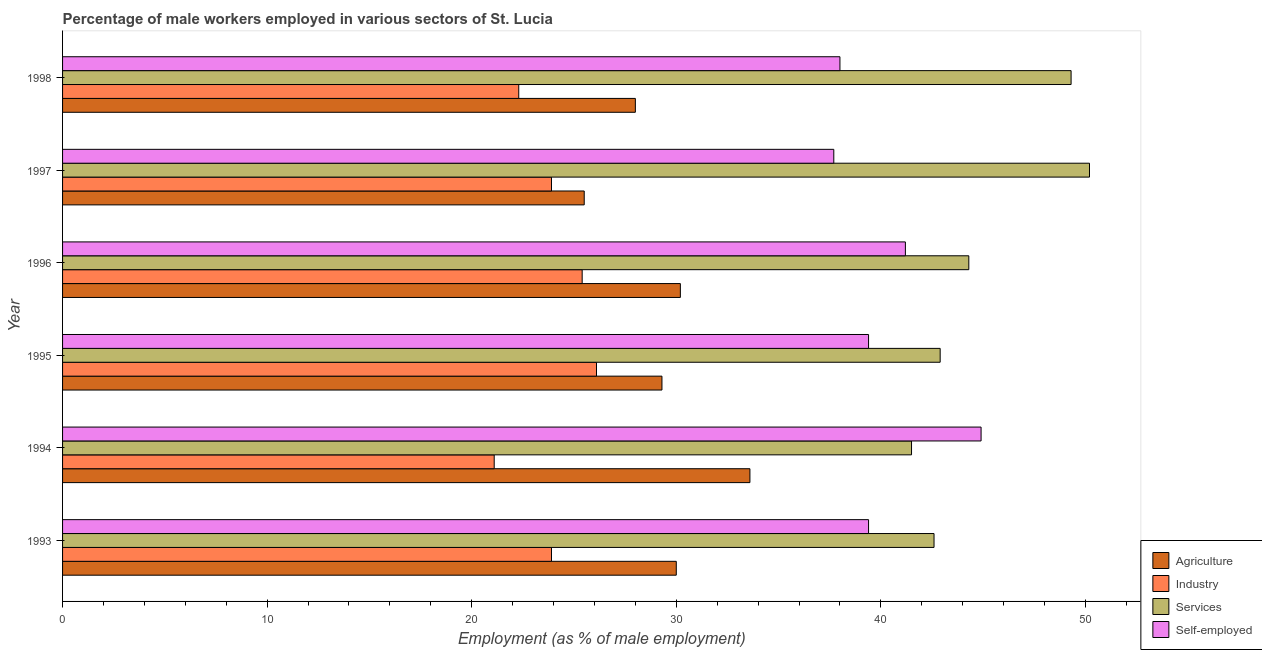How many different coloured bars are there?
Your response must be concise. 4. Are the number of bars on each tick of the Y-axis equal?
Ensure brevity in your answer.  Yes. How many bars are there on the 6th tick from the top?
Give a very brief answer. 4. What is the label of the 5th group of bars from the top?
Give a very brief answer. 1994. What is the percentage of self employed male workers in 1997?
Make the answer very short. 37.7. Across all years, what is the maximum percentage of male workers in services?
Ensure brevity in your answer.  50.2. Across all years, what is the minimum percentage of male workers in agriculture?
Offer a very short reply. 25.5. What is the total percentage of self employed male workers in the graph?
Offer a terse response. 240.6. What is the difference between the percentage of male workers in services in 1996 and that in 1997?
Provide a succinct answer. -5.9. What is the difference between the percentage of male workers in agriculture in 1997 and the percentage of self employed male workers in 1996?
Provide a short and direct response. -15.7. What is the average percentage of male workers in industry per year?
Make the answer very short. 23.78. In the year 1993, what is the difference between the percentage of self employed male workers and percentage of male workers in services?
Your answer should be very brief. -3.2. What is the ratio of the percentage of male workers in industry in 1995 to that in 1997?
Provide a short and direct response. 1.09. Is the percentage of self employed male workers in 1993 less than that in 1997?
Provide a short and direct response. No. Is the difference between the percentage of male workers in industry in 1994 and 1996 greater than the difference between the percentage of self employed male workers in 1994 and 1996?
Your response must be concise. No. Is the sum of the percentage of self employed male workers in 1995 and 1996 greater than the maximum percentage of male workers in services across all years?
Your response must be concise. Yes. What does the 4th bar from the top in 1997 represents?
Give a very brief answer. Agriculture. What does the 3rd bar from the bottom in 1994 represents?
Provide a short and direct response. Services. Are all the bars in the graph horizontal?
Offer a terse response. Yes. Are the values on the major ticks of X-axis written in scientific E-notation?
Provide a succinct answer. No. Does the graph contain any zero values?
Make the answer very short. No. Does the graph contain grids?
Keep it short and to the point. No. Where does the legend appear in the graph?
Your response must be concise. Bottom right. What is the title of the graph?
Make the answer very short. Percentage of male workers employed in various sectors of St. Lucia. What is the label or title of the X-axis?
Offer a terse response. Employment (as % of male employment). What is the label or title of the Y-axis?
Provide a short and direct response. Year. What is the Employment (as % of male employment) of Industry in 1993?
Provide a succinct answer. 23.9. What is the Employment (as % of male employment) in Services in 1993?
Keep it short and to the point. 42.6. What is the Employment (as % of male employment) of Self-employed in 1993?
Provide a succinct answer. 39.4. What is the Employment (as % of male employment) of Agriculture in 1994?
Make the answer very short. 33.6. What is the Employment (as % of male employment) in Industry in 1994?
Provide a succinct answer. 21.1. What is the Employment (as % of male employment) in Services in 1994?
Ensure brevity in your answer.  41.5. What is the Employment (as % of male employment) of Self-employed in 1994?
Offer a very short reply. 44.9. What is the Employment (as % of male employment) of Agriculture in 1995?
Provide a short and direct response. 29.3. What is the Employment (as % of male employment) of Industry in 1995?
Provide a short and direct response. 26.1. What is the Employment (as % of male employment) of Services in 1995?
Offer a terse response. 42.9. What is the Employment (as % of male employment) in Self-employed in 1995?
Provide a short and direct response. 39.4. What is the Employment (as % of male employment) in Agriculture in 1996?
Provide a short and direct response. 30.2. What is the Employment (as % of male employment) of Industry in 1996?
Ensure brevity in your answer.  25.4. What is the Employment (as % of male employment) in Services in 1996?
Provide a short and direct response. 44.3. What is the Employment (as % of male employment) of Self-employed in 1996?
Keep it short and to the point. 41.2. What is the Employment (as % of male employment) of Industry in 1997?
Keep it short and to the point. 23.9. What is the Employment (as % of male employment) in Services in 1997?
Provide a succinct answer. 50.2. What is the Employment (as % of male employment) in Self-employed in 1997?
Provide a succinct answer. 37.7. What is the Employment (as % of male employment) in Agriculture in 1998?
Make the answer very short. 28. What is the Employment (as % of male employment) of Industry in 1998?
Your answer should be very brief. 22.3. What is the Employment (as % of male employment) of Services in 1998?
Keep it short and to the point. 49.3. Across all years, what is the maximum Employment (as % of male employment) in Agriculture?
Offer a terse response. 33.6. Across all years, what is the maximum Employment (as % of male employment) of Industry?
Offer a terse response. 26.1. Across all years, what is the maximum Employment (as % of male employment) in Services?
Offer a very short reply. 50.2. Across all years, what is the maximum Employment (as % of male employment) of Self-employed?
Offer a very short reply. 44.9. Across all years, what is the minimum Employment (as % of male employment) of Industry?
Offer a terse response. 21.1. Across all years, what is the minimum Employment (as % of male employment) of Services?
Give a very brief answer. 41.5. Across all years, what is the minimum Employment (as % of male employment) in Self-employed?
Keep it short and to the point. 37.7. What is the total Employment (as % of male employment) in Agriculture in the graph?
Your answer should be very brief. 176.6. What is the total Employment (as % of male employment) in Industry in the graph?
Your response must be concise. 142.7. What is the total Employment (as % of male employment) in Services in the graph?
Offer a very short reply. 270.8. What is the total Employment (as % of male employment) of Self-employed in the graph?
Provide a succinct answer. 240.6. What is the difference between the Employment (as % of male employment) of Agriculture in 1993 and that in 1994?
Make the answer very short. -3.6. What is the difference between the Employment (as % of male employment) in Self-employed in 1993 and that in 1994?
Your answer should be compact. -5.5. What is the difference between the Employment (as % of male employment) in Agriculture in 1993 and that in 1995?
Keep it short and to the point. 0.7. What is the difference between the Employment (as % of male employment) of Services in 1993 and that in 1995?
Offer a terse response. -0.3. What is the difference between the Employment (as % of male employment) in Agriculture in 1993 and that in 1996?
Keep it short and to the point. -0.2. What is the difference between the Employment (as % of male employment) in Services in 1993 and that in 1996?
Ensure brevity in your answer.  -1.7. What is the difference between the Employment (as % of male employment) in Agriculture in 1993 and that in 1997?
Provide a short and direct response. 4.5. What is the difference between the Employment (as % of male employment) of Industry in 1993 and that in 1998?
Your response must be concise. 1.6. What is the difference between the Employment (as % of male employment) of Services in 1993 and that in 1998?
Give a very brief answer. -6.7. What is the difference between the Employment (as % of male employment) in Services in 1994 and that in 1995?
Offer a terse response. -1.4. What is the difference between the Employment (as % of male employment) in Agriculture in 1994 and that in 1996?
Give a very brief answer. 3.4. What is the difference between the Employment (as % of male employment) in Services in 1994 and that in 1996?
Give a very brief answer. -2.8. What is the difference between the Employment (as % of male employment) of Self-employed in 1994 and that in 1996?
Give a very brief answer. 3.7. What is the difference between the Employment (as % of male employment) of Agriculture in 1994 and that in 1997?
Keep it short and to the point. 8.1. What is the difference between the Employment (as % of male employment) of Industry in 1994 and that in 1997?
Your answer should be compact. -2.8. What is the difference between the Employment (as % of male employment) in Agriculture in 1994 and that in 1998?
Offer a very short reply. 5.6. What is the difference between the Employment (as % of male employment) of Industry in 1994 and that in 1998?
Make the answer very short. -1.2. What is the difference between the Employment (as % of male employment) in Services in 1995 and that in 1996?
Provide a short and direct response. -1.4. What is the difference between the Employment (as % of male employment) of Agriculture in 1995 and that in 1997?
Your response must be concise. 3.8. What is the difference between the Employment (as % of male employment) in Services in 1995 and that in 1997?
Your answer should be very brief. -7.3. What is the difference between the Employment (as % of male employment) of Self-employed in 1995 and that in 1997?
Ensure brevity in your answer.  1.7. What is the difference between the Employment (as % of male employment) of Agriculture in 1995 and that in 1998?
Ensure brevity in your answer.  1.3. What is the difference between the Employment (as % of male employment) of Industry in 1995 and that in 1998?
Your response must be concise. 3.8. What is the difference between the Employment (as % of male employment) of Services in 1995 and that in 1998?
Offer a very short reply. -6.4. What is the difference between the Employment (as % of male employment) of Industry in 1996 and that in 1997?
Provide a short and direct response. 1.5. What is the difference between the Employment (as % of male employment) in Agriculture in 1996 and that in 1998?
Make the answer very short. 2.2. What is the difference between the Employment (as % of male employment) of Industry in 1996 and that in 1998?
Your response must be concise. 3.1. What is the difference between the Employment (as % of male employment) in Services in 1996 and that in 1998?
Offer a very short reply. -5. What is the difference between the Employment (as % of male employment) in Industry in 1997 and that in 1998?
Offer a terse response. 1.6. What is the difference between the Employment (as % of male employment) in Services in 1997 and that in 1998?
Your response must be concise. 0.9. What is the difference between the Employment (as % of male employment) in Self-employed in 1997 and that in 1998?
Ensure brevity in your answer.  -0.3. What is the difference between the Employment (as % of male employment) in Agriculture in 1993 and the Employment (as % of male employment) in Services in 1994?
Provide a short and direct response. -11.5. What is the difference between the Employment (as % of male employment) in Agriculture in 1993 and the Employment (as % of male employment) in Self-employed in 1994?
Provide a short and direct response. -14.9. What is the difference between the Employment (as % of male employment) of Industry in 1993 and the Employment (as % of male employment) of Services in 1994?
Offer a very short reply. -17.6. What is the difference between the Employment (as % of male employment) of Industry in 1993 and the Employment (as % of male employment) of Self-employed in 1994?
Your answer should be compact. -21. What is the difference between the Employment (as % of male employment) of Services in 1993 and the Employment (as % of male employment) of Self-employed in 1994?
Offer a very short reply. -2.3. What is the difference between the Employment (as % of male employment) in Agriculture in 1993 and the Employment (as % of male employment) in Industry in 1995?
Your response must be concise. 3.9. What is the difference between the Employment (as % of male employment) of Agriculture in 1993 and the Employment (as % of male employment) of Services in 1995?
Ensure brevity in your answer.  -12.9. What is the difference between the Employment (as % of male employment) in Agriculture in 1993 and the Employment (as % of male employment) in Self-employed in 1995?
Ensure brevity in your answer.  -9.4. What is the difference between the Employment (as % of male employment) of Industry in 1993 and the Employment (as % of male employment) of Self-employed in 1995?
Make the answer very short. -15.5. What is the difference between the Employment (as % of male employment) of Services in 1993 and the Employment (as % of male employment) of Self-employed in 1995?
Offer a very short reply. 3.2. What is the difference between the Employment (as % of male employment) in Agriculture in 1993 and the Employment (as % of male employment) in Services in 1996?
Make the answer very short. -14.3. What is the difference between the Employment (as % of male employment) in Agriculture in 1993 and the Employment (as % of male employment) in Self-employed in 1996?
Provide a succinct answer. -11.2. What is the difference between the Employment (as % of male employment) of Industry in 1993 and the Employment (as % of male employment) of Services in 1996?
Make the answer very short. -20.4. What is the difference between the Employment (as % of male employment) in Industry in 1993 and the Employment (as % of male employment) in Self-employed in 1996?
Your answer should be compact. -17.3. What is the difference between the Employment (as % of male employment) in Agriculture in 1993 and the Employment (as % of male employment) in Services in 1997?
Offer a very short reply. -20.2. What is the difference between the Employment (as % of male employment) of Industry in 1993 and the Employment (as % of male employment) of Services in 1997?
Your answer should be very brief. -26.3. What is the difference between the Employment (as % of male employment) in Industry in 1993 and the Employment (as % of male employment) in Self-employed in 1997?
Keep it short and to the point. -13.8. What is the difference between the Employment (as % of male employment) of Services in 1993 and the Employment (as % of male employment) of Self-employed in 1997?
Offer a very short reply. 4.9. What is the difference between the Employment (as % of male employment) in Agriculture in 1993 and the Employment (as % of male employment) in Industry in 1998?
Your response must be concise. 7.7. What is the difference between the Employment (as % of male employment) in Agriculture in 1993 and the Employment (as % of male employment) in Services in 1998?
Offer a very short reply. -19.3. What is the difference between the Employment (as % of male employment) in Industry in 1993 and the Employment (as % of male employment) in Services in 1998?
Provide a short and direct response. -25.4. What is the difference between the Employment (as % of male employment) in Industry in 1993 and the Employment (as % of male employment) in Self-employed in 1998?
Your response must be concise. -14.1. What is the difference between the Employment (as % of male employment) of Agriculture in 1994 and the Employment (as % of male employment) of Services in 1995?
Your answer should be very brief. -9.3. What is the difference between the Employment (as % of male employment) of Agriculture in 1994 and the Employment (as % of male employment) of Self-employed in 1995?
Make the answer very short. -5.8. What is the difference between the Employment (as % of male employment) in Industry in 1994 and the Employment (as % of male employment) in Services in 1995?
Your answer should be very brief. -21.8. What is the difference between the Employment (as % of male employment) of Industry in 1994 and the Employment (as % of male employment) of Self-employed in 1995?
Offer a very short reply. -18.3. What is the difference between the Employment (as % of male employment) of Agriculture in 1994 and the Employment (as % of male employment) of Services in 1996?
Provide a short and direct response. -10.7. What is the difference between the Employment (as % of male employment) in Industry in 1994 and the Employment (as % of male employment) in Services in 1996?
Provide a succinct answer. -23.2. What is the difference between the Employment (as % of male employment) in Industry in 1994 and the Employment (as % of male employment) in Self-employed in 1996?
Provide a short and direct response. -20.1. What is the difference between the Employment (as % of male employment) of Services in 1994 and the Employment (as % of male employment) of Self-employed in 1996?
Make the answer very short. 0.3. What is the difference between the Employment (as % of male employment) in Agriculture in 1994 and the Employment (as % of male employment) in Services in 1997?
Keep it short and to the point. -16.6. What is the difference between the Employment (as % of male employment) in Agriculture in 1994 and the Employment (as % of male employment) in Self-employed in 1997?
Offer a terse response. -4.1. What is the difference between the Employment (as % of male employment) in Industry in 1994 and the Employment (as % of male employment) in Services in 1997?
Ensure brevity in your answer.  -29.1. What is the difference between the Employment (as % of male employment) of Industry in 1994 and the Employment (as % of male employment) of Self-employed in 1997?
Offer a very short reply. -16.6. What is the difference between the Employment (as % of male employment) in Agriculture in 1994 and the Employment (as % of male employment) in Services in 1998?
Offer a very short reply. -15.7. What is the difference between the Employment (as % of male employment) of Industry in 1994 and the Employment (as % of male employment) of Services in 1998?
Your answer should be compact. -28.2. What is the difference between the Employment (as % of male employment) in Industry in 1994 and the Employment (as % of male employment) in Self-employed in 1998?
Ensure brevity in your answer.  -16.9. What is the difference between the Employment (as % of male employment) of Agriculture in 1995 and the Employment (as % of male employment) of Industry in 1996?
Your response must be concise. 3.9. What is the difference between the Employment (as % of male employment) in Agriculture in 1995 and the Employment (as % of male employment) in Services in 1996?
Keep it short and to the point. -15. What is the difference between the Employment (as % of male employment) in Industry in 1995 and the Employment (as % of male employment) in Services in 1996?
Ensure brevity in your answer.  -18.2. What is the difference between the Employment (as % of male employment) in Industry in 1995 and the Employment (as % of male employment) in Self-employed in 1996?
Give a very brief answer. -15.1. What is the difference between the Employment (as % of male employment) in Agriculture in 1995 and the Employment (as % of male employment) in Services in 1997?
Provide a short and direct response. -20.9. What is the difference between the Employment (as % of male employment) of Agriculture in 1995 and the Employment (as % of male employment) of Self-employed in 1997?
Your answer should be very brief. -8.4. What is the difference between the Employment (as % of male employment) in Industry in 1995 and the Employment (as % of male employment) in Services in 1997?
Your response must be concise. -24.1. What is the difference between the Employment (as % of male employment) of Agriculture in 1995 and the Employment (as % of male employment) of Services in 1998?
Make the answer very short. -20. What is the difference between the Employment (as % of male employment) in Agriculture in 1995 and the Employment (as % of male employment) in Self-employed in 1998?
Your response must be concise. -8.7. What is the difference between the Employment (as % of male employment) of Industry in 1995 and the Employment (as % of male employment) of Services in 1998?
Provide a short and direct response. -23.2. What is the difference between the Employment (as % of male employment) in Agriculture in 1996 and the Employment (as % of male employment) in Industry in 1997?
Your answer should be compact. 6.3. What is the difference between the Employment (as % of male employment) in Industry in 1996 and the Employment (as % of male employment) in Services in 1997?
Your response must be concise. -24.8. What is the difference between the Employment (as % of male employment) in Industry in 1996 and the Employment (as % of male employment) in Self-employed in 1997?
Give a very brief answer. -12.3. What is the difference between the Employment (as % of male employment) in Agriculture in 1996 and the Employment (as % of male employment) in Industry in 1998?
Your response must be concise. 7.9. What is the difference between the Employment (as % of male employment) in Agriculture in 1996 and the Employment (as % of male employment) in Services in 1998?
Provide a succinct answer. -19.1. What is the difference between the Employment (as % of male employment) of Industry in 1996 and the Employment (as % of male employment) of Services in 1998?
Keep it short and to the point. -23.9. What is the difference between the Employment (as % of male employment) of Services in 1996 and the Employment (as % of male employment) of Self-employed in 1998?
Your response must be concise. 6.3. What is the difference between the Employment (as % of male employment) of Agriculture in 1997 and the Employment (as % of male employment) of Services in 1998?
Give a very brief answer. -23.8. What is the difference between the Employment (as % of male employment) of Industry in 1997 and the Employment (as % of male employment) of Services in 1998?
Ensure brevity in your answer.  -25.4. What is the difference between the Employment (as % of male employment) in Industry in 1997 and the Employment (as % of male employment) in Self-employed in 1998?
Offer a terse response. -14.1. What is the average Employment (as % of male employment) of Agriculture per year?
Make the answer very short. 29.43. What is the average Employment (as % of male employment) of Industry per year?
Keep it short and to the point. 23.78. What is the average Employment (as % of male employment) in Services per year?
Your answer should be very brief. 45.13. What is the average Employment (as % of male employment) of Self-employed per year?
Your answer should be very brief. 40.1. In the year 1993, what is the difference between the Employment (as % of male employment) in Agriculture and Employment (as % of male employment) in Industry?
Make the answer very short. 6.1. In the year 1993, what is the difference between the Employment (as % of male employment) of Agriculture and Employment (as % of male employment) of Services?
Keep it short and to the point. -12.6. In the year 1993, what is the difference between the Employment (as % of male employment) of Agriculture and Employment (as % of male employment) of Self-employed?
Ensure brevity in your answer.  -9.4. In the year 1993, what is the difference between the Employment (as % of male employment) of Industry and Employment (as % of male employment) of Services?
Give a very brief answer. -18.7. In the year 1993, what is the difference between the Employment (as % of male employment) of Industry and Employment (as % of male employment) of Self-employed?
Your answer should be compact. -15.5. In the year 1993, what is the difference between the Employment (as % of male employment) of Services and Employment (as % of male employment) of Self-employed?
Your answer should be very brief. 3.2. In the year 1994, what is the difference between the Employment (as % of male employment) in Industry and Employment (as % of male employment) in Services?
Make the answer very short. -20.4. In the year 1994, what is the difference between the Employment (as % of male employment) of Industry and Employment (as % of male employment) of Self-employed?
Your response must be concise. -23.8. In the year 1995, what is the difference between the Employment (as % of male employment) of Agriculture and Employment (as % of male employment) of Services?
Provide a succinct answer. -13.6. In the year 1995, what is the difference between the Employment (as % of male employment) of Industry and Employment (as % of male employment) of Services?
Your answer should be compact. -16.8. In the year 1995, what is the difference between the Employment (as % of male employment) in Industry and Employment (as % of male employment) in Self-employed?
Give a very brief answer. -13.3. In the year 1996, what is the difference between the Employment (as % of male employment) of Agriculture and Employment (as % of male employment) of Industry?
Make the answer very short. 4.8. In the year 1996, what is the difference between the Employment (as % of male employment) of Agriculture and Employment (as % of male employment) of Services?
Provide a short and direct response. -14.1. In the year 1996, what is the difference between the Employment (as % of male employment) of Agriculture and Employment (as % of male employment) of Self-employed?
Keep it short and to the point. -11. In the year 1996, what is the difference between the Employment (as % of male employment) in Industry and Employment (as % of male employment) in Services?
Offer a terse response. -18.9. In the year 1996, what is the difference between the Employment (as % of male employment) in Industry and Employment (as % of male employment) in Self-employed?
Your answer should be compact. -15.8. In the year 1997, what is the difference between the Employment (as % of male employment) in Agriculture and Employment (as % of male employment) in Services?
Offer a terse response. -24.7. In the year 1997, what is the difference between the Employment (as % of male employment) of Agriculture and Employment (as % of male employment) of Self-employed?
Make the answer very short. -12.2. In the year 1997, what is the difference between the Employment (as % of male employment) in Industry and Employment (as % of male employment) in Services?
Offer a terse response. -26.3. In the year 1997, what is the difference between the Employment (as % of male employment) in Services and Employment (as % of male employment) in Self-employed?
Your answer should be compact. 12.5. In the year 1998, what is the difference between the Employment (as % of male employment) in Agriculture and Employment (as % of male employment) in Services?
Offer a very short reply. -21.3. In the year 1998, what is the difference between the Employment (as % of male employment) in Industry and Employment (as % of male employment) in Self-employed?
Give a very brief answer. -15.7. What is the ratio of the Employment (as % of male employment) of Agriculture in 1993 to that in 1994?
Provide a succinct answer. 0.89. What is the ratio of the Employment (as % of male employment) in Industry in 1993 to that in 1994?
Provide a short and direct response. 1.13. What is the ratio of the Employment (as % of male employment) in Services in 1993 to that in 1994?
Give a very brief answer. 1.03. What is the ratio of the Employment (as % of male employment) of Self-employed in 1993 to that in 1994?
Keep it short and to the point. 0.88. What is the ratio of the Employment (as % of male employment) of Agriculture in 1993 to that in 1995?
Your answer should be compact. 1.02. What is the ratio of the Employment (as % of male employment) in Industry in 1993 to that in 1995?
Keep it short and to the point. 0.92. What is the ratio of the Employment (as % of male employment) of Industry in 1993 to that in 1996?
Provide a short and direct response. 0.94. What is the ratio of the Employment (as % of male employment) in Services in 1993 to that in 1996?
Keep it short and to the point. 0.96. What is the ratio of the Employment (as % of male employment) of Self-employed in 1993 to that in 1996?
Ensure brevity in your answer.  0.96. What is the ratio of the Employment (as % of male employment) of Agriculture in 1993 to that in 1997?
Your answer should be very brief. 1.18. What is the ratio of the Employment (as % of male employment) in Services in 1993 to that in 1997?
Offer a very short reply. 0.85. What is the ratio of the Employment (as % of male employment) of Self-employed in 1993 to that in 1997?
Provide a short and direct response. 1.05. What is the ratio of the Employment (as % of male employment) in Agriculture in 1993 to that in 1998?
Your answer should be very brief. 1.07. What is the ratio of the Employment (as % of male employment) in Industry in 1993 to that in 1998?
Give a very brief answer. 1.07. What is the ratio of the Employment (as % of male employment) in Services in 1993 to that in 1998?
Keep it short and to the point. 0.86. What is the ratio of the Employment (as % of male employment) in Self-employed in 1993 to that in 1998?
Keep it short and to the point. 1.04. What is the ratio of the Employment (as % of male employment) in Agriculture in 1994 to that in 1995?
Make the answer very short. 1.15. What is the ratio of the Employment (as % of male employment) of Industry in 1994 to that in 1995?
Your answer should be compact. 0.81. What is the ratio of the Employment (as % of male employment) of Services in 1994 to that in 1995?
Your response must be concise. 0.97. What is the ratio of the Employment (as % of male employment) in Self-employed in 1994 to that in 1995?
Offer a very short reply. 1.14. What is the ratio of the Employment (as % of male employment) in Agriculture in 1994 to that in 1996?
Your answer should be compact. 1.11. What is the ratio of the Employment (as % of male employment) of Industry in 1994 to that in 1996?
Provide a succinct answer. 0.83. What is the ratio of the Employment (as % of male employment) of Services in 1994 to that in 1996?
Offer a terse response. 0.94. What is the ratio of the Employment (as % of male employment) of Self-employed in 1994 to that in 1996?
Your response must be concise. 1.09. What is the ratio of the Employment (as % of male employment) in Agriculture in 1994 to that in 1997?
Provide a short and direct response. 1.32. What is the ratio of the Employment (as % of male employment) of Industry in 1994 to that in 1997?
Provide a succinct answer. 0.88. What is the ratio of the Employment (as % of male employment) in Services in 1994 to that in 1997?
Keep it short and to the point. 0.83. What is the ratio of the Employment (as % of male employment) in Self-employed in 1994 to that in 1997?
Your answer should be compact. 1.19. What is the ratio of the Employment (as % of male employment) in Industry in 1994 to that in 1998?
Ensure brevity in your answer.  0.95. What is the ratio of the Employment (as % of male employment) of Services in 1994 to that in 1998?
Your response must be concise. 0.84. What is the ratio of the Employment (as % of male employment) in Self-employed in 1994 to that in 1998?
Give a very brief answer. 1.18. What is the ratio of the Employment (as % of male employment) in Agriculture in 1995 to that in 1996?
Offer a very short reply. 0.97. What is the ratio of the Employment (as % of male employment) of Industry in 1995 to that in 1996?
Give a very brief answer. 1.03. What is the ratio of the Employment (as % of male employment) in Services in 1995 to that in 1996?
Offer a terse response. 0.97. What is the ratio of the Employment (as % of male employment) of Self-employed in 1995 to that in 1996?
Your response must be concise. 0.96. What is the ratio of the Employment (as % of male employment) in Agriculture in 1995 to that in 1997?
Offer a very short reply. 1.15. What is the ratio of the Employment (as % of male employment) in Industry in 1995 to that in 1997?
Offer a very short reply. 1.09. What is the ratio of the Employment (as % of male employment) in Services in 1995 to that in 1997?
Make the answer very short. 0.85. What is the ratio of the Employment (as % of male employment) in Self-employed in 1995 to that in 1997?
Offer a very short reply. 1.05. What is the ratio of the Employment (as % of male employment) in Agriculture in 1995 to that in 1998?
Provide a succinct answer. 1.05. What is the ratio of the Employment (as % of male employment) in Industry in 1995 to that in 1998?
Your answer should be compact. 1.17. What is the ratio of the Employment (as % of male employment) in Services in 1995 to that in 1998?
Offer a very short reply. 0.87. What is the ratio of the Employment (as % of male employment) in Self-employed in 1995 to that in 1998?
Offer a terse response. 1.04. What is the ratio of the Employment (as % of male employment) of Agriculture in 1996 to that in 1997?
Your response must be concise. 1.18. What is the ratio of the Employment (as % of male employment) of Industry in 1996 to that in 1997?
Offer a very short reply. 1.06. What is the ratio of the Employment (as % of male employment) of Services in 1996 to that in 1997?
Offer a very short reply. 0.88. What is the ratio of the Employment (as % of male employment) in Self-employed in 1996 to that in 1997?
Provide a succinct answer. 1.09. What is the ratio of the Employment (as % of male employment) of Agriculture in 1996 to that in 1998?
Offer a terse response. 1.08. What is the ratio of the Employment (as % of male employment) in Industry in 1996 to that in 1998?
Give a very brief answer. 1.14. What is the ratio of the Employment (as % of male employment) of Services in 1996 to that in 1998?
Your answer should be very brief. 0.9. What is the ratio of the Employment (as % of male employment) in Self-employed in 1996 to that in 1998?
Give a very brief answer. 1.08. What is the ratio of the Employment (as % of male employment) of Agriculture in 1997 to that in 1998?
Make the answer very short. 0.91. What is the ratio of the Employment (as % of male employment) of Industry in 1997 to that in 1998?
Ensure brevity in your answer.  1.07. What is the ratio of the Employment (as % of male employment) in Services in 1997 to that in 1998?
Your answer should be very brief. 1.02. What is the ratio of the Employment (as % of male employment) in Self-employed in 1997 to that in 1998?
Provide a succinct answer. 0.99. What is the difference between the highest and the second highest Employment (as % of male employment) in Services?
Provide a succinct answer. 0.9. What is the difference between the highest and the second highest Employment (as % of male employment) of Self-employed?
Make the answer very short. 3.7. What is the difference between the highest and the lowest Employment (as % of male employment) of Agriculture?
Your answer should be compact. 8.1. What is the difference between the highest and the lowest Employment (as % of male employment) in Services?
Your response must be concise. 8.7. What is the difference between the highest and the lowest Employment (as % of male employment) in Self-employed?
Provide a succinct answer. 7.2. 